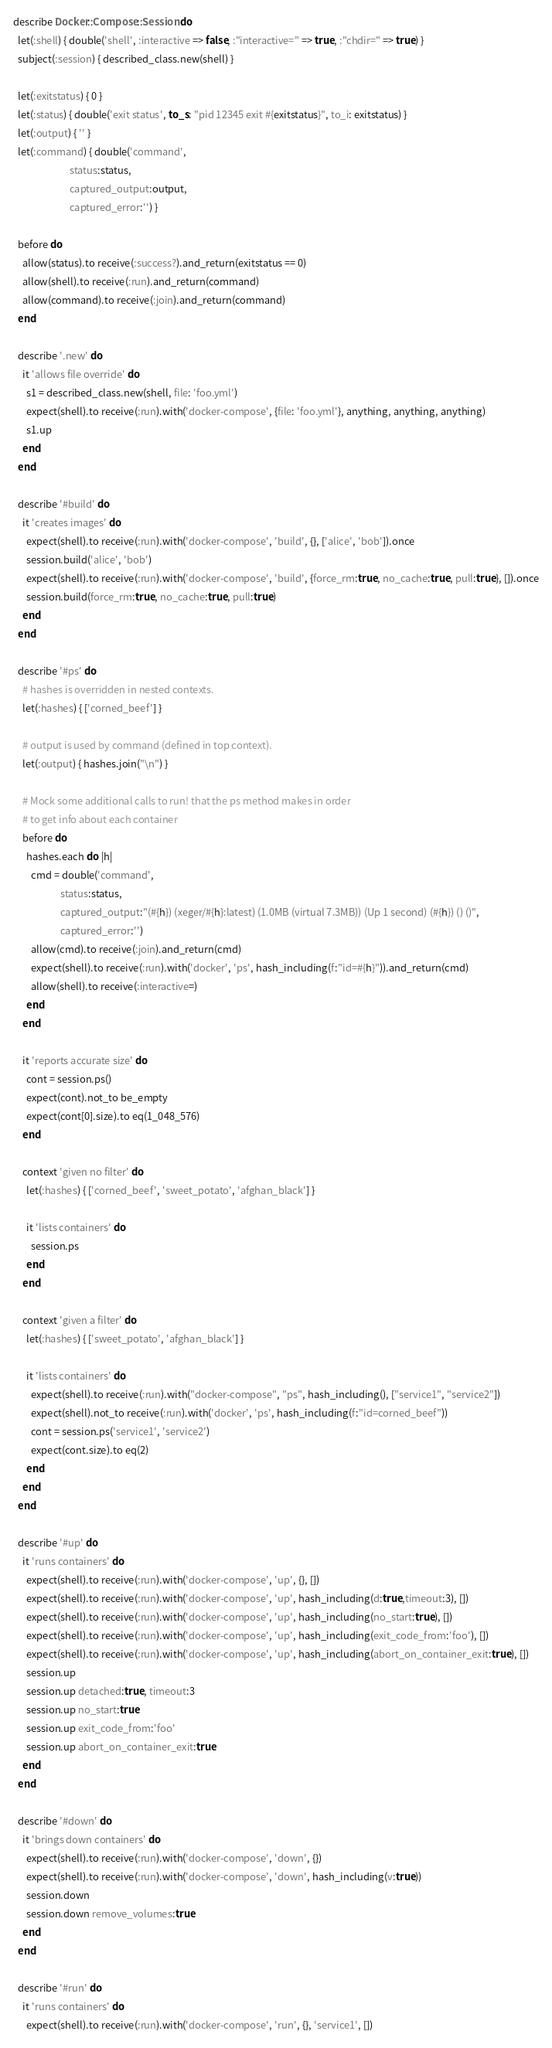<code> <loc_0><loc_0><loc_500><loc_500><_Ruby_>describe Docker::Compose::Session do
  let(:shell) { double('shell', :interactive => false, :"interactive=" => true, :"chdir=" => true) }
  subject(:session) { described_class.new(shell) }

  let(:exitstatus) { 0 }
  let(:status) { double('exit status', to_s: "pid 12345 exit #{exitstatus}", to_i: exitstatus) }
  let(:output) { '' }
  let(:command) { double('command',
                         status:status,
                         captured_output:output,
                         captured_error:'') }

  before do
    allow(status).to receive(:success?).and_return(exitstatus == 0)
    allow(shell).to receive(:run).and_return(command)
    allow(command).to receive(:join).and_return(command)
  end

  describe '.new' do
    it 'allows file override' do
      s1 = described_class.new(shell, file: 'foo.yml')
      expect(shell).to receive(:run).with('docker-compose', {file: 'foo.yml'}, anything, anything, anything)
      s1.up
    end
  end

  describe '#build' do
    it 'creates images' do
      expect(shell).to receive(:run).with('docker-compose', 'build', {}, ['alice', 'bob']).once
      session.build('alice', 'bob')
      expect(shell).to receive(:run).with('docker-compose', 'build', {force_rm:true, no_cache:true, pull:true}, []).once
      session.build(force_rm:true, no_cache:true, pull:true)
    end
  end

  describe '#ps' do
    # hashes is overridden in nested contexts.
    let(:hashes) { ['corned_beef'] }

    # output is used by command (defined in top context).
    let(:output) { hashes.join("\n") }

    # Mock some additional calls to run! that the ps method makes in order
    # to get info about each container
    before do
      hashes.each do |h|
        cmd = double('command',
                     status:status,
                     captured_output:"(#{h}) (xeger/#{h}:latest) (1.0MB (virtual 7.3MB)) (Up 1 second) (#{h}) () ()",
                     captured_error:'')
        allow(cmd).to receive(:join).and_return(cmd)
        expect(shell).to receive(:run).with('docker', 'ps', hash_including(f:"id=#{h}")).and_return(cmd)
        allow(shell).to receive(:interactive=)
      end
    end

    it 'reports accurate size' do
      cont = session.ps()
      expect(cont).not_to be_empty
      expect(cont[0].size).to eq(1_048_576)
    end

    context 'given no filter' do
      let(:hashes) { ['corned_beef', 'sweet_potato', 'afghan_black'] }

      it 'lists containers' do
        session.ps
      end
    end

    context 'given a filter' do
      let(:hashes) { ['sweet_potato', 'afghan_black'] }

      it 'lists containers' do
        expect(shell).to receive(:run).with("docker-compose", "ps", hash_including(), ["service1", "service2"])
        expect(shell).not_to receive(:run).with('docker', 'ps', hash_including(f:"id=corned_beef"))
        cont = session.ps('service1', 'service2')
        expect(cont.size).to eq(2)
      end
    end
  end

  describe '#up' do
    it 'runs containers' do
      expect(shell).to receive(:run).with('docker-compose', 'up', {}, [])
      expect(shell).to receive(:run).with('docker-compose', 'up', hash_including(d:true,timeout:3), [])
      expect(shell).to receive(:run).with('docker-compose', 'up', hash_including(no_start:true), [])
      expect(shell).to receive(:run).with('docker-compose', 'up', hash_including(exit_code_from:'foo'), [])
      expect(shell).to receive(:run).with('docker-compose', 'up', hash_including(abort_on_container_exit:true), [])
      session.up
      session.up detached:true, timeout:3
      session.up no_start:true
      session.up exit_code_from:'foo'
      session.up abort_on_container_exit:true
    end
  end

  describe '#down' do
    it 'brings down containers' do
      expect(shell).to receive(:run).with('docker-compose', 'down', {})
      expect(shell).to receive(:run).with('docker-compose', 'down', hash_including(v:true))
      session.down
      session.down remove_volumes:true
    end
  end

  describe '#run' do
    it 'runs containers' do
      expect(shell).to receive(:run).with('docker-compose', 'run', {}, 'service1', [])</code> 